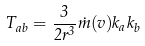<formula> <loc_0><loc_0><loc_500><loc_500>T _ { a b } = \frac { 3 } { 2 r ^ { 3 } } \dot { m } ( v ) k _ { a } k _ { b }</formula> 